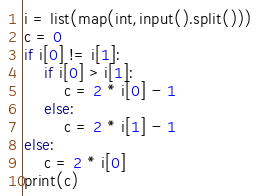<code> <loc_0><loc_0><loc_500><loc_500><_Python_>i = list(map(int,input().split()))
c = 0
if i[0] != i[1]:
    if i[0] > i[1]:
        c = 2 * i[0] - 1
    else:
        c = 2 * i[1] - 1
else:
    c = 2 * i[0]
print(c)</code> 